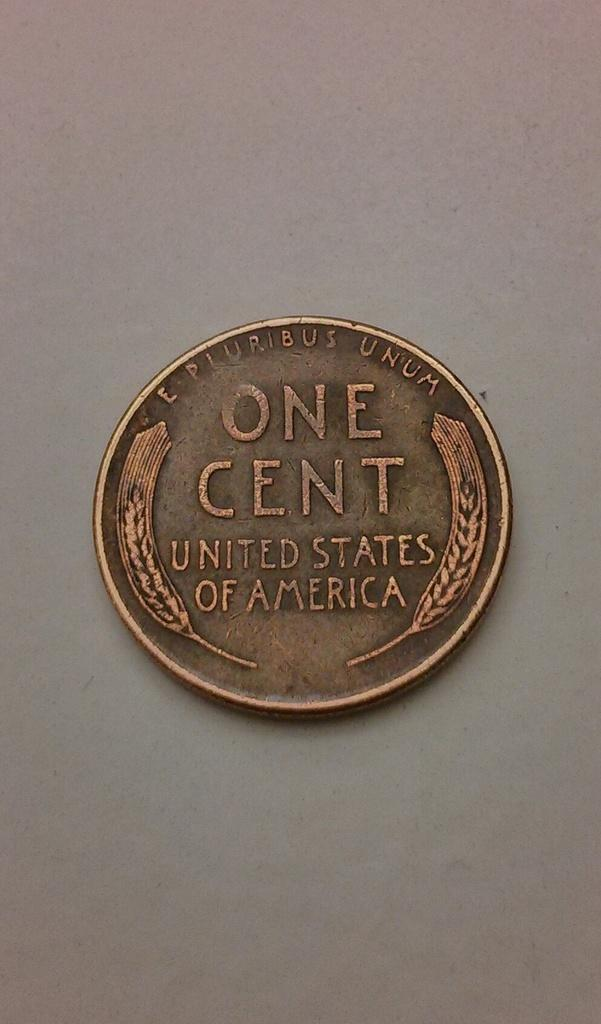What type of coin is visible in the image? There is a coin of USA in the image. What is the color of the coin? The coin is brown in color. On what surface is the coin placed? The coin is placed on a white surface. What type of music can be heard coming from the stove in the image? There is no stove present in the image, and therefore no music can be heard from it. 